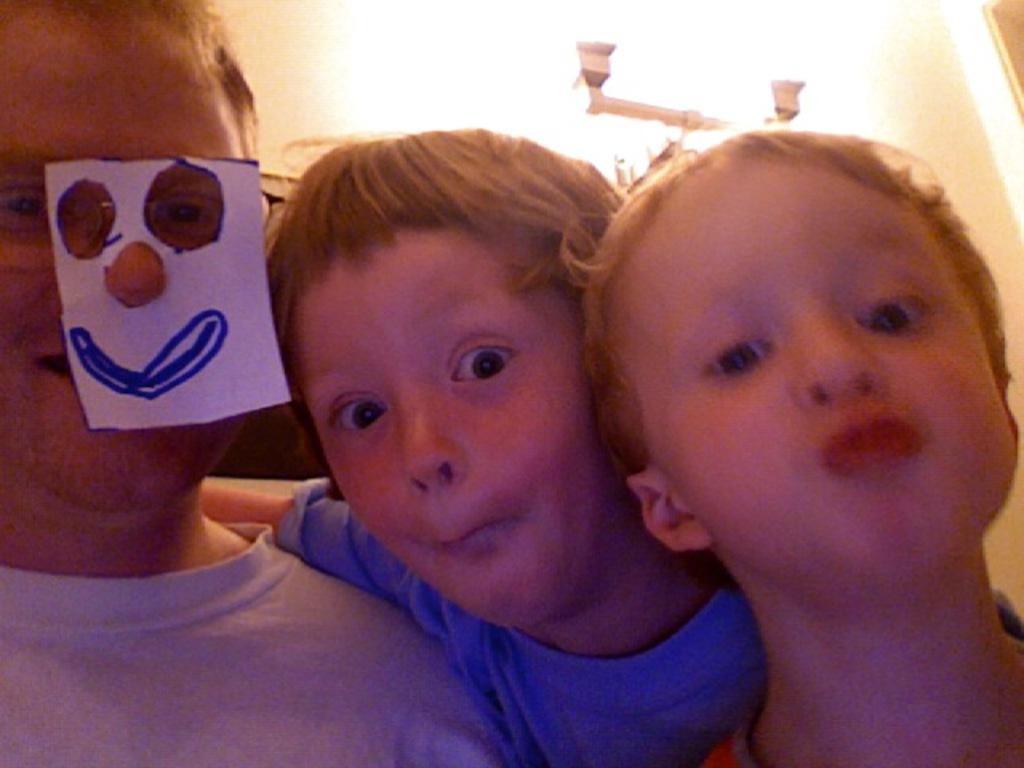Please provide a concise description of this image. In the foreground of the picture we can see three persons. In the background we can see wall, light, stand and other objects. 